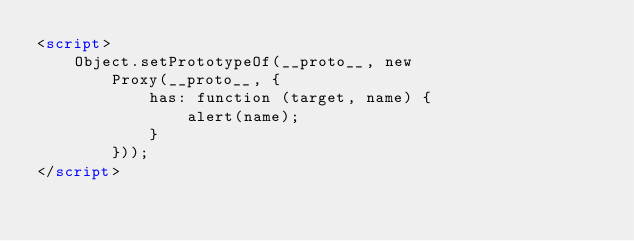<code> <loc_0><loc_0><loc_500><loc_500><_HTML_><script>
    Object.setPrototypeOf(__proto__, new
        Proxy(__proto__, {
            has: function (target, name) {
                alert(name);
            }
        }));
</script></code> 